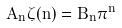<formula> <loc_0><loc_0><loc_500><loc_500>A _ { n } \zeta ( n ) = B _ { n } \pi ^ { n }</formula> 